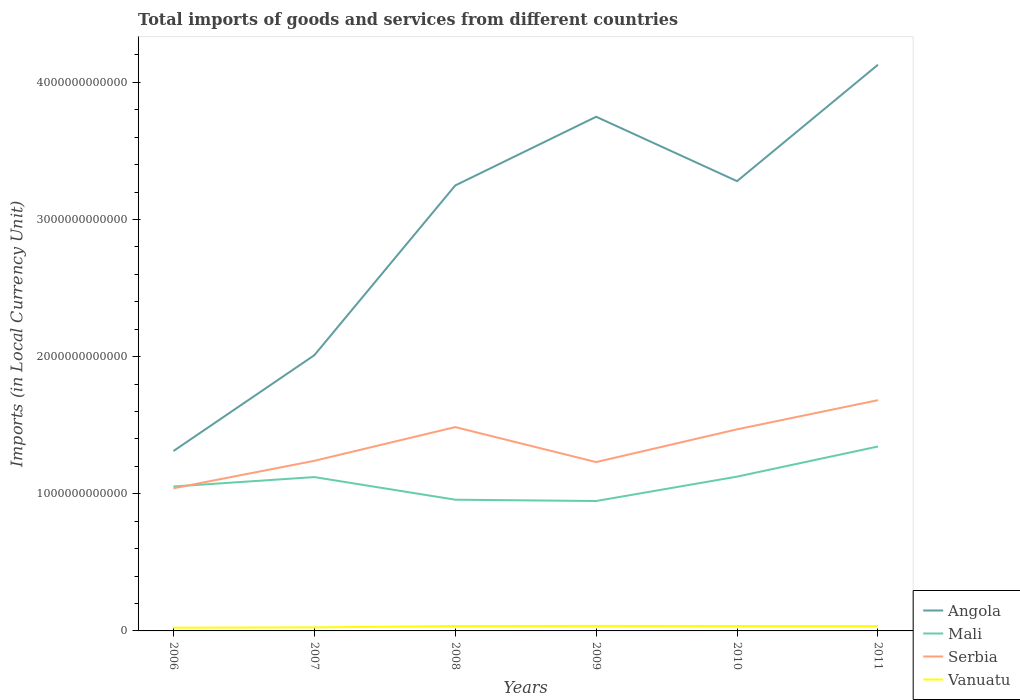How many different coloured lines are there?
Provide a succinct answer. 4. Does the line corresponding to Mali intersect with the line corresponding to Vanuatu?
Make the answer very short. No. Is the number of lines equal to the number of legend labels?
Your answer should be compact. Yes. Across all years, what is the maximum Amount of goods and services imports in Serbia?
Offer a very short reply. 1.04e+12. What is the total Amount of goods and services imports in Serbia in the graph?
Offer a very short reply. -2.39e+11. What is the difference between the highest and the second highest Amount of goods and services imports in Angola?
Your response must be concise. 2.82e+12. What is the difference between the highest and the lowest Amount of goods and services imports in Mali?
Ensure brevity in your answer.  3. Is the Amount of goods and services imports in Serbia strictly greater than the Amount of goods and services imports in Mali over the years?
Offer a terse response. No. How many lines are there?
Provide a short and direct response. 4. What is the difference between two consecutive major ticks on the Y-axis?
Your response must be concise. 1.00e+12. Does the graph contain any zero values?
Your response must be concise. No. Where does the legend appear in the graph?
Give a very brief answer. Bottom right. How are the legend labels stacked?
Offer a very short reply. Vertical. What is the title of the graph?
Your answer should be very brief. Total imports of goods and services from different countries. Does "Ghana" appear as one of the legend labels in the graph?
Keep it short and to the point. No. What is the label or title of the Y-axis?
Keep it short and to the point. Imports (in Local Currency Unit). What is the Imports (in Local Currency Unit) in Angola in 2006?
Offer a very short reply. 1.31e+12. What is the Imports (in Local Currency Unit) in Mali in 2006?
Keep it short and to the point. 1.05e+12. What is the Imports (in Local Currency Unit) of Serbia in 2006?
Your answer should be very brief. 1.04e+12. What is the Imports (in Local Currency Unit) in Vanuatu in 2006?
Give a very brief answer. 2.35e+1. What is the Imports (in Local Currency Unit) of Angola in 2007?
Offer a very short reply. 2.01e+12. What is the Imports (in Local Currency Unit) in Mali in 2007?
Provide a succinct answer. 1.12e+12. What is the Imports (in Local Currency Unit) in Serbia in 2007?
Offer a terse response. 1.24e+12. What is the Imports (in Local Currency Unit) of Vanuatu in 2007?
Make the answer very short. 2.57e+1. What is the Imports (in Local Currency Unit) of Angola in 2008?
Provide a succinct answer. 3.25e+12. What is the Imports (in Local Currency Unit) of Mali in 2008?
Make the answer very short. 9.57e+11. What is the Imports (in Local Currency Unit) of Serbia in 2008?
Make the answer very short. 1.49e+12. What is the Imports (in Local Currency Unit) in Vanuatu in 2008?
Ensure brevity in your answer.  3.55e+1. What is the Imports (in Local Currency Unit) of Angola in 2009?
Give a very brief answer. 3.75e+12. What is the Imports (in Local Currency Unit) of Mali in 2009?
Your answer should be compact. 9.47e+11. What is the Imports (in Local Currency Unit) of Serbia in 2009?
Offer a terse response. 1.23e+12. What is the Imports (in Local Currency Unit) of Vanuatu in 2009?
Give a very brief answer. 3.66e+1. What is the Imports (in Local Currency Unit) in Angola in 2010?
Make the answer very short. 3.28e+12. What is the Imports (in Local Currency Unit) of Mali in 2010?
Your response must be concise. 1.12e+12. What is the Imports (in Local Currency Unit) in Serbia in 2010?
Provide a succinct answer. 1.47e+12. What is the Imports (in Local Currency Unit) of Vanuatu in 2010?
Provide a succinct answer. 3.58e+1. What is the Imports (in Local Currency Unit) in Angola in 2011?
Your response must be concise. 4.13e+12. What is the Imports (in Local Currency Unit) in Mali in 2011?
Give a very brief answer. 1.34e+12. What is the Imports (in Local Currency Unit) in Serbia in 2011?
Keep it short and to the point. 1.68e+12. What is the Imports (in Local Currency Unit) of Vanuatu in 2011?
Provide a short and direct response. 3.54e+1. Across all years, what is the maximum Imports (in Local Currency Unit) of Angola?
Give a very brief answer. 4.13e+12. Across all years, what is the maximum Imports (in Local Currency Unit) in Mali?
Offer a very short reply. 1.34e+12. Across all years, what is the maximum Imports (in Local Currency Unit) of Serbia?
Make the answer very short. 1.68e+12. Across all years, what is the maximum Imports (in Local Currency Unit) of Vanuatu?
Provide a succinct answer. 3.66e+1. Across all years, what is the minimum Imports (in Local Currency Unit) of Angola?
Provide a short and direct response. 1.31e+12. Across all years, what is the minimum Imports (in Local Currency Unit) of Mali?
Provide a succinct answer. 9.47e+11. Across all years, what is the minimum Imports (in Local Currency Unit) of Serbia?
Keep it short and to the point. 1.04e+12. Across all years, what is the minimum Imports (in Local Currency Unit) of Vanuatu?
Give a very brief answer. 2.35e+1. What is the total Imports (in Local Currency Unit) in Angola in the graph?
Offer a very short reply. 1.77e+13. What is the total Imports (in Local Currency Unit) of Mali in the graph?
Keep it short and to the point. 6.55e+12. What is the total Imports (in Local Currency Unit) of Serbia in the graph?
Your response must be concise. 8.15e+12. What is the total Imports (in Local Currency Unit) of Vanuatu in the graph?
Offer a very short reply. 1.93e+11. What is the difference between the Imports (in Local Currency Unit) in Angola in 2006 and that in 2007?
Make the answer very short. -6.99e+11. What is the difference between the Imports (in Local Currency Unit) in Mali in 2006 and that in 2007?
Make the answer very short. -6.87e+1. What is the difference between the Imports (in Local Currency Unit) in Serbia in 2006 and that in 2007?
Offer a terse response. -2.00e+11. What is the difference between the Imports (in Local Currency Unit) in Vanuatu in 2006 and that in 2007?
Your response must be concise. -2.24e+09. What is the difference between the Imports (in Local Currency Unit) of Angola in 2006 and that in 2008?
Make the answer very short. -1.94e+12. What is the difference between the Imports (in Local Currency Unit) in Mali in 2006 and that in 2008?
Offer a very short reply. 9.62e+1. What is the difference between the Imports (in Local Currency Unit) in Serbia in 2006 and that in 2008?
Your answer should be very brief. -4.46e+11. What is the difference between the Imports (in Local Currency Unit) in Vanuatu in 2006 and that in 2008?
Provide a short and direct response. -1.20e+1. What is the difference between the Imports (in Local Currency Unit) in Angola in 2006 and that in 2009?
Ensure brevity in your answer.  -2.44e+12. What is the difference between the Imports (in Local Currency Unit) of Mali in 2006 and that in 2009?
Keep it short and to the point. 1.06e+11. What is the difference between the Imports (in Local Currency Unit) of Serbia in 2006 and that in 2009?
Keep it short and to the point. -1.91e+11. What is the difference between the Imports (in Local Currency Unit) in Vanuatu in 2006 and that in 2009?
Your response must be concise. -1.32e+1. What is the difference between the Imports (in Local Currency Unit) in Angola in 2006 and that in 2010?
Provide a short and direct response. -1.97e+12. What is the difference between the Imports (in Local Currency Unit) in Mali in 2006 and that in 2010?
Provide a short and direct response. -7.20e+1. What is the difference between the Imports (in Local Currency Unit) in Serbia in 2006 and that in 2010?
Your response must be concise. -4.30e+11. What is the difference between the Imports (in Local Currency Unit) of Vanuatu in 2006 and that in 2010?
Make the answer very short. -1.24e+1. What is the difference between the Imports (in Local Currency Unit) of Angola in 2006 and that in 2011?
Offer a terse response. -2.82e+12. What is the difference between the Imports (in Local Currency Unit) in Mali in 2006 and that in 2011?
Provide a succinct answer. -2.92e+11. What is the difference between the Imports (in Local Currency Unit) of Serbia in 2006 and that in 2011?
Make the answer very short. -6.43e+11. What is the difference between the Imports (in Local Currency Unit) in Vanuatu in 2006 and that in 2011?
Ensure brevity in your answer.  -1.19e+1. What is the difference between the Imports (in Local Currency Unit) in Angola in 2007 and that in 2008?
Provide a succinct answer. -1.24e+12. What is the difference between the Imports (in Local Currency Unit) of Mali in 2007 and that in 2008?
Ensure brevity in your answer.  1.65e+11. What is the difference between the Imports (in Local Currency Unit) in Serbia in 2007 and that in 2008?
Offer a very short reply. -2.46e+11. What is the difference between the Imports (in Local Currency Unit) of Vanuatu in 2007 and that in 2008?
Provide a short and direct response. -9.80e+09. What is the difference between the Imports (in Local Currency Unit) in Angola in 2007 and that in 2009?
Your response must be concise. -1.74e+12. What is the difference between the Imports (in Local Currency Unit) in Mali in 2007 and that in 2009?
Offer a very short reply. 1.74e+11. What is the difference between the Imports (in Local Currency Unit) in Serbia in 2007 and that in 2009?
Ensure brevity in your answer.  9.18e+09. What is the difference between the Imports (in Local Currency Unit) of Vanuatu in 2007 and that in 2009?
Your response must be concise. -1.09e+1. What is the difference between the Imports (in Local Currency Unit) of Angola in 2007 and that in 2010?
Your response must be concise. -1.27e+12. What is the difference between the Imports (in Local Currency Unit) in Mali in 2007 and that in 2010?
Give a very brief answer. -3.34e+09. What is the difference between the Imports (in Local Currency Unit) in Serbia in 2007 and that in 2010?
Give a very brief answer. -2.30e+11. What is the difference between the Imports (in Local Currency Unit) of Vanuatu in 2007 and that in 2010?
Provide a succinct answer. -1.01e+1. What is the difference between the Imports (in Local Currency Unit) of Angola in 2007 and that in 2011?
Offer a terse response. -2.12e+12. What is the difference between the Imports (in Local Currency Unit) of Mali in 2007 and that in 2011?
Keep it short and to the point. -2.23e+11. What is the difference between the Imports (in Local Currency Unit) in Serbia in 2007 and that in 2011?
Your answer should be very brief. -4.42e+11. What is the difference between the Imports (in Local Currency Unit) in Vanuatu in 2007 and that in 2011?
Ensure brevity in your answer.  -9.71e+09. What is the difference between the Imports (in Local Currency Unit) of Angola in 2008 and that in 2009?
Offer a very short reply. -5.01e+11. What is the difference between the Imports (in Local Currency Unit) of Mali in 2008 and that in 2009?
Give a very brief answer. 9.57e+09. What is the difference between the Imports (in Local Currency Unit) in Serbia in 2008 and that in 2009?
Your answer should be compact. 2.55e+11. What is the difference between the Imports (in Local Currency Unit) in Vanuatu in 2008 and that in 2009?
Give a very brief answer. -1.15e+09. What is the difference between the Imports (in Local Currency Unit) in Angola in 2008 and that in 2010?
Ensure brevity in your answer.  -3.15e+1. What is the difference between the Imports (in Local Currency Unit) in Mali in 2008 and that in 2010?
Ensure brevity in your answer.  -1.68e+11. What is the difference between the Imports (in Local Currency Unit) of Serbia in 2008 and that in 2010?
Ensure brevity in your answer.  1.62e+1. What is the difference between the Imports (in Local Currency Unit) of Vanuatu in 2008 and that in 2010?
Keep it short and to the point. -3.19e+08. What is the difference between the Imports (in Local Currency Unit) of Angola in 2008 and that in 2011?
Give a very brief answer. -8.80e+11. What is the difference between the Imports (in Local Currency Unit) in Mali in 2008 and that in 2011?
Your answer should be very brief. -3.88e+11. What is the difference between the Imports (in Local Currency Unit) in Serbia in 2008 and that in 2011?
Your answer should be very brief. -1.96e+11. What is the difference between the Imports (in Local Currency Unit) in Vanuatu in 2008 and that in 2011?
Offer a terse response. 8.50e+07. What is the difference between the Imports (in Local Currency Unit) of Angola in 2009 and that in 2010?
Your response must be concise. 4.69e+11. What is the difference between the Imports (in Local Currency Unit) in Mali in 2009 and that in 2010?
Keep it short and to the point. -1.78e+11. What is the difference between the Imports (in Local Currency Unit) in Serbia in 2009 and that in 2010?
Keep it short and to the point. -2.39e+11. What is the difference between the Imports (in Local Currency Unit) in Vanuatu in 2009 and that in 2010?
Offer a very short reply. 8.31e+08. What is the difference between the Imports (in Local Currency Unit) in Angola in 2009 and that in 2011?
Provide a succinct answer. -3.79e+11. What is the difference between the Imports (in Local Currency Unit) in Mali in 2009 and that in 2011?
Your answer should be compact. -3.97e+11. What is the difference between the Imports (in Local Currency Unit) of Serbia in 2009 and that in 2011?
Keep it short and to the point. -4.51e+11. What is the difference between the Imports (in Local Currency Unit) of Vanuatu in 2009 and that in 2011?
Provide a succinct answer. 1.24e+09. What is the difference between the Imports (in Local Currency Unit) of Angola in 2010 and that in 2011?
Offer a terse response. -8.49e+11. What is the difference between the Imports (in Local Currency Unit) of Mali in 2010 and that in 2011?
Give a very brief answer. -2.20e+11. What is the difference between the Imports (in Local Currency Unit) of Serbia in 2010 and that in 2011?
Provide a short and direct response. -2.13e+11. What is the difference between the Imports (in Local Currency Unit) in Vanuatu in 2010 and that in 2011?
Ensure brevity in your answer.  4.04e+08. What is the difference between the Imports (in Local Currency Unit) in Angola in 2006 and the Imports (in Local Currency Unit) in Mali in 2007?
Offer a very short reply. 1.90e+11. What is the difference between the Imports (in Local Currency Unit) in Angola in 2006 and the Imports (in Local Currency Unit) in Serbia in 2007?
Provide a succinct answer. 7.14e+1. What is the difference between the Imports (in Local Currency Unit) in Angola in 2006 and the Imports (in Local Currency Unit) in Vanuatu in 2007?
Your answer should be compact. 1.29e+12. What is the difference between the Imports (in Local Currency Unit) in Mali in 2006 and the Imports (in Local Currency Unit) in Serbia in 2007?
Make the answer very short. -1.87e+11. What is the difference between the Imports (in Local Currency Unit) of Mali in 2006 and the Imports (in Local Currency Unit) of Vanuatu in 2007?
Your response must be concise. 1.03e+12. What is the difference between the Imports (in Local Currency Unit) in Serbia in 2006 and the Imports (in Local Currency Unit) in Vanuatu in 2007?
Give a very brief answer. 1.01e+12. What is the difference between the Imports (in Local Currency Unit) in Angola in 2006 and the Imports (in Local Currency Unit) in Mali in 2008?
Provide a succinct answer. 3.55e+11. What is the difference between the Imports (in Local Currency Unit) of Angola in 2006 and the Imports (in Local Currency Unit) of Serbia in 2008?
Provide a short and direct response. -1.74e+11. What is the difference between the Imports (in Local Currency Unit) in Angola in 2006 and the Imports (in Local Currency Unit) in Vanuatu in 2008?
Ensure brevity in your answer.  1.28e+12. What is the difference between the Imports (in Local Currency Unit) in Mali in 2006 and the Imports (in Local Currency Unit) in Serbia in 2008?
Your answer should be compact. -4.33e+11. What is the difference between the Imports (in Local Currency Unit) of Mali in 2006 and the Imports (in Local Currency Unit) of Vanuatu in 2008?
Your answer should be compact. 1.02e+12. What is the difference between the Imports (in Local Currency Unit) in Serbia in 2006 and the Imports (in Local Currency Unit) in Vanuatu in 2008?
Ensure brevity in your answer.  1.00e+12. What is the difference between the Imports (in Local Currency Unit) in Angola in 2006 and the Imports (in Local Currency Unit) in Mali in 2009?
Your answer should be compact. 3.64e+11. What is the difference between the Imports (in Local Currency Unit) of Angola in 2006 and the Imports (in Local Currency Unit) of Serbia in 2009?
Ensure brevity in your answer.  8.06e+1. What is the difference between the Imports (in Local Currency Unit) in Angola in 2006 and the Imports (in Local Currency Unit) in Vanuatu in 2009?
Keep it short and to the point. 1.28e+12. What is the difference between the Imports (in Local Currency Unit) of Mali in 2006 and the Imports (in Local Currency Unit) of Serbia in 2009?
Provide a short and direct response. -1.78e+11. What is the difference between the Imports (in Local Currency Unit) in Mali in 2006 and the Imports (in Local Currency Unit) in Vanuatu in 2009?
Your answer should be compact. 1.02e+12. What is the difference between the Imports (in Local Currency Unit) in Serbia in 2006 and the Imports (in Local Currency Unit) in Vanuatu in 2009?
Provide a succinct answer. 1.00e+12. What is the difference between the Imports (in Local Currency Unit) of Angola in 2006 and the Imports (in Local Currency Unit) of Mali in 2010?
Keep it short and to the point. 1.87e+11. What is the difference between the Imports (in Local Currency Unit) in Angola in 2006 and the Imports (in Local Currency Unit) in Serbia in 2010?
Give a very brief answer. -1.58e+11. What is the difference between the Imports (in Local Currency Unit) of Angola in 2006 and the Imports (in Local Currency Unit) of Vanuatu in 2010?
Give a very brief answer. 1.28e+12. What is the difference between the Imports (in Local Currency Unit) in Mali in 2006 and the Imports (in Local Currency Unit) in Serbia in 2010?
Offer a terse response. -4.17e+11. What is the difference between the Imports (in Local Currency Unit) in Mali in 2006 and the Imports (in Local Currency Unit) in Vanuatu in 2010?
Provide a succinct answer. 1.02e+12. What is the difference between the Imports (in Local Currency Unit) of Serbia in 2006 and the Imports (in Local Currency Unit) of Vanuatu in 2010?
Ensure brevity in your answer.  1.00e+12. What is the difference between the Imports (in Local Currency Unit) of Angola in 2006 and the Imports (in Local Currency Unit) of Mali in 2011?
Your response must be concise. -3.29e+1. What is the difference between the Imports (in Local Currency Unit) of Angola in 2006 and the Imports (in Local Currency Unit) of Serbia in 2011?
Make the answer very short. -3.71e+11. What is the difference between the Imports (in Local Currency Unit) in Angola in 2006 and the Imports (in Local Currency Unit) in Vanuatu in 2011?
Give a very brief answer. 1.28e+12. What is the difference between the Imports (in Local Currency Unit) in Mali in 2006 and the Imports (in Local Currency Unit) in Serbia in 2011?
Your answer should be very brief. -6.29e+11. What is the difference between the Imports (in Local Currency Unit) of Mali in 2006 and the Imports (in Local Currency Unit) of Vanuatu in 2011?
Provide a succinct answer. 1.02e+12. What is the difference between the Imports (in Local Currency Unit) of Serbia in 2006 and the Imports (in Local Currency Unit) of Vanuatu in 2011?
Offer a very short reply. 1.00e+12. What is the difference between the Imports (in Local Currency Unit) of Angola in 2007 and the Imports (in Local Currency Unit) of Mali in 2008?
Provide a short and direct response. 1.05e+12. What is the difference between the Imports (in Local Currency Unit) in Angola in 2007 and the Imports (in Local Currency Unit) in Serbia in 2008?
Your response must be concise. 5.24e+11. What is the difference between the Imports (in Local Currency Unit) of Angola in 2007 and the Imports (in Local Currency Unit) of Vanuatu in 2008?
Provide a short and direct response. 1.97e+12. What is the difference between the Imports (in Local Currency Unit) in Mali in 2007 and the Imports (in Local Currency Unit) in Serbia in 2008?
Make the answer very short. -3.64e+11. What is the difference between the Imports (in Local Currency Unit) in Mali in 2007 and the Imports (in Local Currency Unit) in Vanuatu in 2008?
Provide a short and direct response. 1.09e+12. What is the difference between the Imports (in Local Currency Unit) in Serbia in 2007 and the Imports (in Local Currency Unit) in Vanuatu in 2008?
Give a very brief answer. 1.20e+12. What is the difference between the Imports (in Local Currency Unit) in Angola in 2007 and the Imports (in Local Currency Unit) in Mali in 2009?
Your answer should be very brief. 1.06e+12. What is the difference between the Imports (in Local Currency Unit) of Angola in 2007 and the Imports (in Local Currency Unit) of Serbia in 2009?
Your answer should be compact. 7.79e+11. What is the difference between the Imports (in Local Currency Unit) of Angola in 2007 and the Imports (in Local Currency Unit) of Vanuatu in 2009?
Your answer should be very brief. 1.97e+12. What is the difference between the Imports (in Local Currency Unit) of Mali in 2007 and the Imports (in Local Currency Unit) of Serbia in 2009?
Your answer should be very brief. -1.09e+11. What is the difference between the Imports (in Local Currency Unit) in Mali in 2007 and the Imports (in Local Currency Unit) in Vanuatu in 2009?
Give a very brief answer. 1.08e+12. What is the difference between the Imports (in Local Currency Unit) of Serbia in 2007 and the Imports (in Local Currency Unit) of Vanuatu in 2009?
Your answer should be very brief. 1.20e+12. What is the difference between the Imports (in Local Currency Unit) in Angola in 2007 and the Imports (in Local Currency Unit) in Mali in 2010?
Ensure brevity in your answer.  8.85e+11. What is the difference between the Imports (in Local Currency Unit) of Angola in 2007 and the Imports (in Local Currency Unit) of Serbia in 2010?
Keep it short and to the point. 5.40e+11. What is the difference between the Imports (in Local Currency Unit) of Angola in 2007 and the Imports (in Local Currency Unit) of Vanuatu in 2010?
Ensure brevity in your answer.  1.97e+12. What is the difference between the Imports (in Local Currency Unit) in Mali in 2007 and the Imports (in Local Currency Unit) in Serbia in 2010?
Offer a terse response. -3.48e+11. What is the difference between the Imports (in Local Currency Unit) in Mali in 2007 and the Imports (in Local Currency Unit) in Vanuatu in 2010?
Give a very brief answer. 1.09e+12. What is the difference between the Imports (in Local Currency Unit) of Serbia in 2007 and the Imports (in Local Currency Unit) of Vanuatu in 2010?
Provide a succinct answer. 1.20e+12. What is the difference between the Imports (in Local Currency Unit) of Angola in 2007 and the Imports (in Local Currency Unit) of Mali in 2011?
Ensure brevity in your answer.  6.66e+11. What is the difference between the Imports (in Local Currency Unit) in Angola in 2007 and the Imports (in Local Currency Unit) in Serbia in 2011?
Provide a short and direct response. 3.28e+11. What is the difference between the Imports (in Local Currency Unit) in Angola in 2007 and the Imports (in Local Currency Unit) in Vanuatu in 2011?
Provide a short and direct response. 1.97e+12. What is the difference between the Imports (in Local Currency Unit) in Mali in 2007 and the Imports (in Local Currency Unit) in Serbia in 2011?
Ensure brevity in your answer.  -5.61e+11. What is the difference between the Imports (in Local Currency Unit) of Mali in 2007 and the Imports (in Local Currency Unit) of Vanuatu in 2011?
Give a very brief answer. 1.09e+12. What is the difference between the Imports (in Local Currency Unit) of Serbia in 2007 and the Imports (in Local Currency Unit) of Vanuatu in 2011?
Provide a succinct answer. 1.20e+12. What is the difference between the Imports (in Local Currency Unit) in Angola in 2008 and the Imports (in Local Currency Unit) in Mali in 2009?
Your response must be concise. 2.30e+12. What is the difference between the Imports (in Local Currency Unit) in Angola in 2008 and the Imports (in Local Currency Unit) in Serbia in 2009?
Make the answer very short. 2.02e+12. What is the difference between the Imports (in Local Currency Unit) of Angola in 2008 and the Imports (in Local Currency Unit) of Vanuatu in 2009?
Offer a very short reply. 3.21e+12. What is the difference between the Imports (in Local Currency Unit) of Mali in 2008 and the Imports (in Local Currency Unit) of Serbia in 2009?
Offer a terse response. -2.74e+11. What is the difference between the Imports (in Local Currency Unit) in Mali in 2008 and the Imports (in Local Currency Unit) in Vanuatu in 2009?
Ensure brevity in your answer.  9.20e+11. What is the difference between the Imports (in Local Currency Unit) of Serbia in 2008 and the Imports (in Local Currency Unit) of Vanuatu in 2009?
Offer a terse response. 1.45e+12. What is the difference between the Imports (in Local Currency Unit) of Angola in 2008 and the Imports (in Local Currency Unit) of Mali in 2010?
Keep it short and to the point. 2.12e+12. What is the difference between the Imports (in Local Currency Unit) in Angola in 2008 and the Imports (in Local Currency Unit) in Serbia in 2010?
Your response must be concise. 1.78e+12. What is the difference between the Imports (in Local Currency Unit) of Angola in 2008 and the Imports (in Local Currency Unit) of Vanuatu in 2010?
Your response must be concise. 3.21e+12. What is the difference between the Imports (in Local Currency Unit) of Mali in 2008 and the Imports (in Local Currency Unit) of Serbia in 2010?
Make the answer very short. -5.13e+11. What is the difference between the Imports (in Local Currency Unit) of Mali in 2008 and the Imports (in Local Currency Unit) of Vanuatu in 2010?
Provide a short and direct response. 9.21e+11. What is the difference between the Imports (in Local Currency Unit) of Serbia in 2008 and the Imports (in Local Currency Unit) of Vanuatu in 2010?
Your response must be concise. 1.45e+12. What is the difference between the Imports (in Local Currency Unit) in Angola in 2008 and the Imports (in Local Currency Unit) in Mali in 2011?
Your answer should be very brief. 1.90e+12. What is the difference between the Imports (in Local Currency Unit) of Angola in 2008 and the Imports (in Local Currency Unit) of Serbia in 2011?
Offer a very short reply. 1.57e+12. What is the difference between the Imports (in Local Currency Unit) of Angola in 2008 and the Imports (in Local Currency Unit) of Vanuatu in 2011?
Your answer should be compact. 3.21e+12. What is the difference between the Imports (in Local Currency Unit) in Mali in 2008 and the Imports (in Local Currency Unit) in Serbia in 2011?
Your answer should be compact. -7.26e+11. What is the difference between the Imports (in Local Currency Unit) in Mali in 2008 and the Imports (in Local Currency Unit) in Vanuatu in 2011?
Offer a very short reply. 9.21e+11. What is the difference between the Imports (in Local Currency Unit) in Serbia in 2008 and the Imports (in Local Currency Unit) in Vanuatu in 2011?
Your answer should be very brief. 1.45e+12. What is the difference between the Imports (in Local Currency Unit) in Angola in 2009 and the Imports (in Local Currency Unit) in Mali in 2010?
Offer a very short reply. 2.62e+12. What is the difference between the Imports (in Local Currency Unit) in Angola in 2009 and the Imports (in Local Currency Unit) in Serbia in 2010?
Provide a short and direct response. 2.28e+12. What is the difference between the Imports (in Local Currency Unit) in Angola in 2009 and the Imports (in Local Currency Unit) in Vanuatu in 2010?
Provide a short and direct response. 3.71e+12. What is the difference between the Imports (in Local Currency Unit) in Mali in 2009 and the Imports (in Local Currency Unit) in Serbia in 2010?
Keep it short and to the point. -5.23e+11. What is the difference between the Imports (in Local Currency Unit) of Mali in 2009 and the Imports (in Local Currency Unit) of Vanuatu in 2010?
Make the answer very short. 9.11e+11. What is the difference between the Imports (in Local Currency Unit) in Serbia in 2009 and the Imports (in Local Currency Unit) in Vanuatu in 2010?
Your answer should be compact. 1.20e+12. What is the difference between the Imports (in Local Currency Unit) in Angola in 2009 and the Imports (in Local Currency Unit) in Mali in 2011?
Keep it short and to the point. 2.40e+12. What is the difference between the Imports (in Local Currency Unit) in Angola in 2009 and the Imports (in Local Currency Unit) in Serbia in 2011?
Provide a short and direct response. 2.07e+12. What is the difference between the Imports (in Local Currency Unit) in Angola in 2009 and the Imports (in Local Currency Unit) in Vanuatu in 2011?
Ensure brevity in your answer.  3.71e+12. What is the difference between the Imports (in Local Currency Unit) in Mali in 2009 and the Imports (in Local Currency Unit) in Serbia in 2011?
Give a very brief answer. -7.35e+11. What is the difference between the Imports (in Local Currency Unit) in Mali in 2009 and the Imports (in Local Currency Unit) in Vanuatu in 2011?
Give a very brief answer. 9.12e+11. What is the difference between the Imports (in Local Currency Unit) in Serbia in 2009 and the Imports (in Local Currency Unit) in Vanuatu in 2011?
Your answer should be very brief. 1.20e+12. What is the difference between the Imports (in Local Currency Unit) in Angola in 2010 and the Imports (in Local Currency Unit) in Mali in 2011?
Your answer should be compact. 1.93e+12. What is the difference between the Imports (in Local Currency Unit) in Angola in 2010 and the Imports (in Local Currency Unit) in Serbia in 2011?
Offer a very short reply. 1.60e+12. What is the difference between the Imports (in Local Currency Unit) of Angola in 2010 and the Imports (in Local Currency Unit) of Vanuatu in 2011?
Make the answer very short. 3.24e+12. What is the difference between the Imports (in Local Currency Unit) in Mali in 2010 and the Imports (in Local Currency Unit) in Serbia in 2011?
Ensure brevity in your answer.  -5.57e+11. What is the difference between the Imports (in Local Currency Unit) of Mali in 2010 and the Imports (in Local Currency Unit) of Vanuatu in 2011?
Provide a short and direct response. 1.09e+12. What is the difference between the Imports (in Local Currency Unit) of Serbia in 2010 and the Imports (in Local Currency Unit) of Vanuatu in 2011?
Offer a terse response. 1.43e+12. What is the average Imports (in Local Currency Unit) of Angola per year?
Provide a short and direct response. 2.95e+12. What is the average Imports (in Local Currency Unit) of Mali per year?
Provide a succinct answer. 1.09e+12. What is the average Imports (in Local Currency Unit) of Serbia per year?
Provide a short and direct response. 1.36e+12. What is the average Imports (in Local Currency Unit) of Vanuatu per year?
Provide a succinct answer. 3.21e+1. In the year 2006, what is the difference between the Imports (in Local Currency Unit) of Angola and Imports (in Local Currency Unit) of Mali?
Provide a succinct answer. 2.59e+11. In the year 2006, what is the difference between the Imports (in Local Currency Unit) in Angola and Imports (in Local Currency Unit) in Serbia?
Keep it short and to the point. 2.72e+11. In the year 2006, what is the difference between the Imports (in Local Currency Unit) of Angola and Imports (in Local Currency Unit) of Vanuatu?
Ensure brevity in your answer.  1.29e+12. In the year 2006, what is the difference between the Imports (in Local Currency Unit) in Mali and Imports (in Local Currency Unit) in Serbia?
Ensure brevity in your answer.  1.30e+1. In the year 2006, what is the difference between the Imports (in Local Currency Unit) in Mali and Imports (in Local Currency Unit) in Vanuatu?
Your answer should be compact. 1.03e+12. In the year 2006, what is the difference between the Imports (in Local Currency Unit) of Serbia and Imports (in Local Currency Unit) of Vanuatu?
Make the answer very short. 1.02e+12. In the year 2007, what is the difference between the Imports (in Local Currency Unit) of Angola and Imports (in Local Currency Unit) of Mali?
Make the answer very short. 8.89e+11. In the year 2007, what is the difference between the Imports (in Local Currency Unit) of Angola and Imports (in Local Currency Unit) of Serbia?
Provide a short and direct response. 7.70e+11. In the year 2007, what is the difference between the Imports (in Local Currency Unit) of Angola and Imports (in Local Currency Unit) of Vanuatu?
Keep it short and to the point. 1.98e+12. In the year 2007, what is the difference between the Imports (in Local Currency Unit) of Mali and Imports (in Local Currency Unit) of Serbia?
Offer a terse response. -1.19e+11. In the year 2007, what is the difference between the Imports (in Local Currency Unit) of Mali and Imports (in Local Currency Unit) of Vanuatu?
Offer a very short reply. 1.10e+12. In the year 2007, what is the difference between the Imports (in Local Currency Unit) of Serbia and Imports (in Local Currency Unit) of Vanuatu?
Provide a succinct answer. 1.21e+12. In the year 2008, what is the difference between the Imports (in Local Currency Unit) in Angola and Imports (in Local Currency Unit) in Mali?
Keep it short and to the point. 2.29e+12. In the year 2008, what is the difference between the Imports (in Local Currency Unit) in Angola and Imports (in Local Currency Unit) in Serbia?
Make the answer very short. 1.76e+12. In the year 2008, what is the difference between the Imports (in Local Currency Unit) in Angola and Imports (in Local Currency Unit) in Vanuatu?
Provide a succinct answer. 3.21e+12. In the year 2008, what is the difference between the Imports (in Local Currency Unit) in Mali and Imports (in Local Currency Unit) in Serbia?
Ensure brevity in your answer.  -5.29e+11. In the year 2008, what is the difference between the Imports (in Local Currency Unit) of Mali and Imports (in Local Currency Unit) of Vanuatu?
Offer a terse response. 9.21e+11. In the year 2008, what is the difference between the Imports (in Local Currency Unit) of Serbia and Imports (in Local Currency Unit) of Vanuatu?
Your answer should be compact. 1.45e+12. In the year 2009, what is the difference between the Imports (in Local Currency Unit) in Angola and Imports (in Local Currency Unit) in Mali?
Your response must be concise. 2.80e+12. In the year 2009, what is the difference between the Imports (in Local Currency Unit) of Angola and Imports (in Local Currency Unit) of Serbia?
Make the answer very short. 2.52e+12. In the year 2009, what is the difference between the Imports (in Local Currency Unit) of Angola and Imports (in Local Currency Unit) of Vanuatu?
Ensure brevity in your answer.  3.71e+12. In the year 2009, what is the difference between the Imports (in Local Currency Unit) in Mali and Imports (in Local Currency Unit) in Serbia?
Provide a succinct answer. -2.84e+11. In the year 2009, what is the difference between the Imports (in Local Currency Unit) in Mali and Imports (in Local Currency Unit) in Vanuatu?
Offer a terse response. 9.11e+11. In the year 2009, what is the difference between the Imports (in Local Currency Unit) in Serbia and Imports (in Local Currency Unit) in Vanuatu?
Keep it short and to the point. 1.19e+12. In the year 2010, what is the difference between the Imports (in Local Currency Unit) in Angola and Imports (in Local Currency Unit) in Mali?
Your answer should be very brief. 2.15e+12. In the year 2010, what is the difference between the Imports (in Local Currency Unit) in Angola and Imports (in Local Currency Unit) in Serbia?
Offer a terse response. 1.81e+12. In the year 2010, what is the difference between the Imports (in Local Currency Unit) of Angola and Imports (in Local Currency Unit) of Vanuatu?
Your response must be concise. 3.24e+12. In the year 2010, what is the difference between the Imports (in Local Currency Unit) in Mali and Imports (in Local Currency Unit) in Serbia?
Offer a very short reply. -3.45e+11. In the year 2010, what is the difference between the Imports (in Local Currency Unit) in Mali and Imports (in Local Currency Unit) in Vanuatu?
Provide a succinct answer. 1.09e+12. In the year 2010, what is the difference between the Imports (in Local Currency Unit) of Serbia and Imports (in Local Currency Unit) of Vanuatu?
Your response must be concise. 1.43e+12. In the year 2011, what is the difference between the Imports (in Local Currency Unit) of Angola and Imports (in Local Currency Unit) of Mali?
Keep it short and to the point. 2.78e+12. In the year 2011, what is the difference between the Imports (in Local Currency Unit) of Angola and Imports (in Local Currency Unit) of Serbia?
Your response must be concise. 2.45e+12. In the year 2011, what is the difference between the Imports (in Local Currency Unit) of Angola and Imports (in Local Currency Unit) of Vanuatu?
Give a very brief answer. 4.09e+12. In the year 2011, what is the difference between the Imports (in Local Currency Unit) of Mali and Imports (in Local Currency Unit) of Serbia?
Your answer should be very brief. -3.38e+11. In the year 2011, what is the difference between the Imports (in Local Currency Unit) in Mali and Imports (in Local Currency Unit) in Vanuatu?
Ensure brevity in your answer.  1.31e+12. In the year 2011, what is the difference between the Imports (in Local Currency Unit) in Serbia and Imports (in Local Currency Unit) in Vanuatu?
Your response must be concise. 1.65e+12. What is the ratio of the Imports (in Local Currency Unit) of Angola in 2006 to that in 2007?
Your answer should be very brief. 0.65. What is the ratio of the Imports (in Local Currency Unit) of Mali in 2006 to that in 2007?
Provide a short and direct response. 0.94. What is the ratio of the Imports (in Local Currency Unit) in Serbia in 2006 to that in 2007?
Your answer should be very brief. 0.84. What is the ratio of the Imports (in Local Currency Unit) in Angola in 2006 to that in 2008?
Ensure brevity in your answer.  0.4. What is the ratio of the Imports (in Local Currency Unit) in Mali in 2006 to that in 2008?
Provide a succinct answer. 1.1. What is the ratio of the Imports (in Local Currency Unit) of Serbia in 2006 to that in 2008?
Give a very brief answer. 0.7. What is the ratio of the Imports (in Local Currency Unit) in Vanuatu in 2006 to that in 2008?
Provide a succinct answer. 0.66. What is the ratio of the Imports (in Local Currency Unit) of Angola in 2006 to that in 2009?
Provide a short and direct response. 0.35. What is the ratio of the Imports (in Local Currency Unit) in Mali in 2006 to that in 2009?
Provide a succinct answer. 1.11. What is the ratio of the Imports (in Local Currency Unit) of Serbia in 2006 to that in 2009?
Your answer should be compact. 0.84. What is the ratio of the Imports (in Local Currency Unit) of Vanuatu in 2006 to that in 2009?
Your answer should be very brief. 0.64. What is the ratio of the Imports (in Local Currency Unit) of Angola in 2006 to that in 2010?
Your response must be concise. 0.4. What is the ratio of the Imports (in Local Currency Unit) of Mali in 2006 to that in 2010?
Your response must be concise. 0.94. What is the ratio of the Imports (in Local Currency Unit) of Serbia in 2006 to that in 2010?
Offer a very short reply. 0.71. What is the ratio of the Imports (in Local Currency Unit) in Vanuatu in 2006 to that in 2010?
Offer a terse response. 0.66. What is the ratio of the Imports (in Local Currency Unit) in Angola in 2006 to that in 2011?
Ensure brevity in your answer.  0.32. What is the ratio of the Imports (in Local Currency Unit) of Mali in 2006 to that in 2011?
Your answer should be very brief. 0.78. What is the ratio of the Imports (in Local Currency Unit) of Serbia in 2006 to that in 2011?
Make the answer very short. 0.62. What is the ratio of the Imports (in Local Currency Unit) of Vanuatu in 2006 to that in 2011?
Provide a succinct answer. 0.66. What is the ratio of the Imports (in Local Currency Unit) in Angola in 2007 to that in 2008?
Your answer should be very brief. 0.62. What is the ratio of the Imports (in Local Currency Unit) of Mali in 2007 to that in 2008?
Offer a terse response. 1.17. What is the ratio of the Imports (in Local Currency Unit) in Serbia in 2007 to that in 2008?
Keep it short and to the point. 0.83. What is the ratio of the Imports (in Local Currency Unit) in Vanuatu in 2007 to that in 2008?
Your answer should be very brief. 0.72. What is the ratio of the Imports (in Local Currency Unit) of Angola in 2007 to that in 2009?
Ensure brevity in your answer.  0.54. What is the ratio of the Imports (in Local Currency Unit) of Mali in 2007 to that in 2009?
Your answer should be compact. 1.18. What is the ratio of the Imports (in Local Currency Unit) of Serbia in 2007 to that in 2009?
Provide a short and direct response. 1.01. What is the ratio of the Imports (in Local Currency Unit) of Vanuatu in 2007 to that in 2009?
Provide a short and direct response. 0.7. What is the ratio of the Imports (in Local Currency Unit) of Angola in 2007 to that in 2010?
Offer a very short reply. 0.61. What is the ratio of the Imports (in Local Currency Unit) of Serbia in 2007 to that in 2010?
Offer a very short reply. 0.84. What is the ratio of the Imports (in Local Currency Unit) of Vanuatu in 2007 to that in 2010?
Provide a succinct answer. 0.72. What is the ratio of the Imports (in Local Currency Unit) of Angola in 2007 to that in 2011?
Offer a terse response. 0.49. What is the ratio of the Imports (in Local Currency Unit) of Mali in 2007 to that in 2011?
Provide a succinct answer. 0.83. What is the ratio of the Imports (in Local Currency Unit) in Serbia in 2007 to that in 2011?
Ensure brevity in your answer.  0.74. What is the ratio of the Imports (in Local Currency Unit) of Vanuatu in 2007 to that in 2011?
Ensure brevity in your answer.  0.73. What is the ratio of the Imports (in Local Currency Unit) of Angola in 2008 to that in 2009?
Offer a very short reply. 0.87. What is the ratio of the Imports (in Local Currency Unit) in Mali in 2008 to that in 2009?
Offer a terse response. 1.01. What is the ratio of the Imports (in Local Currency Unit) of Serbia in 2008 to that in 2009?
Offer a very short reply. 1.21. What is the ratio of the Imports (in Local Currency Unit) in Vanuatu in 2008 to that in 2009?
Ensure brevity in your answer.  0.97. What is the ratio of the Imports (in Local Currency Unit) in Mali in 2008 to that in 2010?
Offer a terse response. 0.85. What is the ratio of the Imports (in Local Currency Unit) in Serbia in 2008 to that in 2010?
Make the answer very short. 1.01. What is the ratio of the Imports (in Local Currency Unit) in Angola in 2008 to that in 2011?
Offer a terse response. 0.79. What is the ratio of the Imports (in Local Currency Unit) in Mali in 2008 to that in 2011?
Offer a very short reply. 0.71. What is the ratio of the Imports (in Local Currency Unit) of Serbia in 2008 to that in 2011?
Your response must be concise. 0.88. What is the ratio of the Imports (in Local Currency Unit) of Angola in 2009 to that in 2010?
Your response must be concise. 1.14. What is the ratio of the Imports (in Local Currency Unit) of Mali in 2009 to that in 2010?
Offer a very short reply. 0.84. What is the ratio of the Imports (in Local Currency Unit) in Serbia in 2009 to that in 2010?
Provide a short and direct response. 0.84. What is the ratio of the Imports (in Local Currency Unit) of Vanuatu in 2009 to that in 2010?
Your answer should be very brief. 1.02. What is the ratio of the Imports (in Local Currency Unit) in Angola in 2009 to that in 2011?
Your response must be concise. 0.91. What is the ratio of the Imports (in Local Currency Unit) in Mali in 2009 to that in 2011?
Your answer should be very brief. 0.7. What is the ratio of the Imports (in Local Currency Unit) in Serbia in 2009 to that in 2011?
Your answer should be very brief. 0.73. What is the ratio of the Imports (in Local Currency Unit) in Vanuatu in 2009 to that in 2011?
Provide a succinct answer. 1.03. What is the ratio of the Imports (in Local Currency Unit) in Angola in 2010 to that in 2011?
Provide a short and direct response. 0.79. What is the ratio of the Imports (in Local Currency Unit) of Mali in 2010 to that in 2011?
Provide a succinct answer. 0.84. What is the ratio of the Imports (in Local Currency Unit) in Serbia in 2010 to that in 2011?
Your response must be concise. 0.87. What is the ratio of the Imports (in Local Currency Unit) of Vanuatu in 2010 to that in 2011?
Your answer should be compact. 1.01. What is the difference between the highest and the second highest Imports (in Local Currency Unit) in Angola?
Your answer should be compact. 3.79e+11. What is the difference between the highest and the second highest Imports (in Local Currency Unit) of Mali?
Your answer should be compact. 2.20e+11. What is the difference between the highest and the second highest Imports (in Local Currency Unit) of Serbia?
Offer a very short reply. 1.96e+11. What is the difference between the highest and the second highest Imports (in Local Currency Unit) in Vanuatu?
Offer a terse response. 8.31e+08. What is the difference between the highest and the lowest Imports (in Local Currency Unit) in Angola?
Provide a short and direct response. 2.82e+12. What is the difference between the highest and the lowest Imports (in Local Currency Unit) in Mali?
Your response must be concise. 3.97e+11. What is the difference between the highest and the lowest Imports (in Local Currency Unit) of Serbia?
Your response must be concise. 6.43e+11. What is the difference between the highest and the lowest Imports (in Local Currency Unit) in Vanuatu?
Make the answer very short. 1.32e+1. 